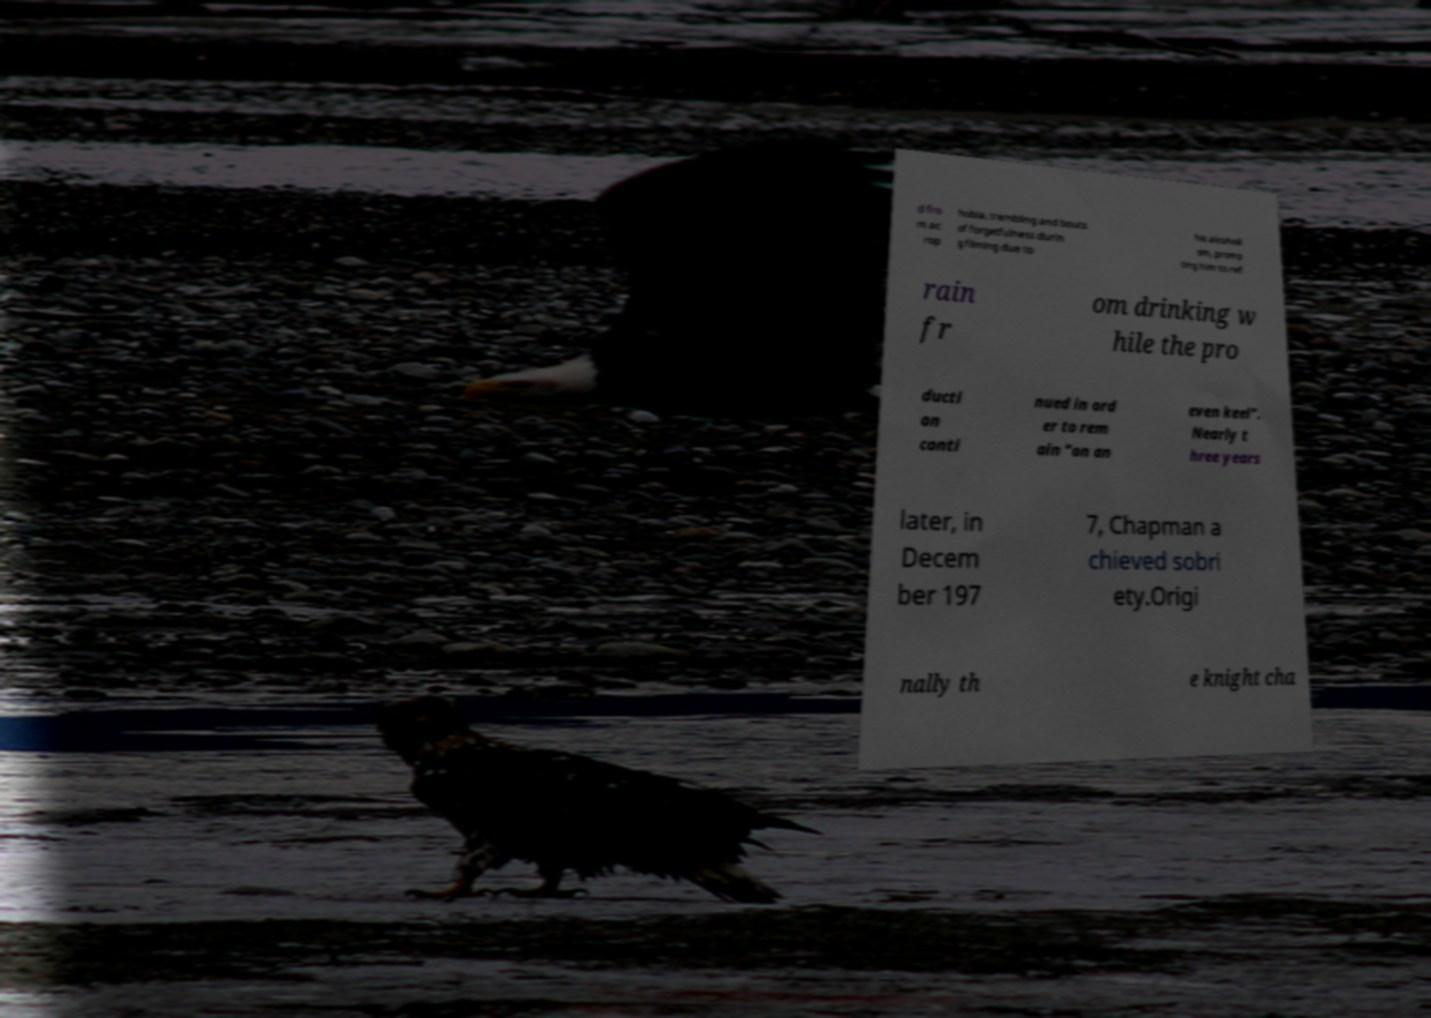I need the written content from this picture converted into text. Can you do that? d fro m ac rop hobia, trembling and bouts of forgetfulness durin g filming due to his alcoholi sm, promp ting him to ref rain fr om drinking w hile the pro ducti on conti nued in ord er to rem ain "on an even keel". Nearly t hree years later, in Decem ber 197 7, Chapman a chieved sobri ety.Origi nally th e knight cha 